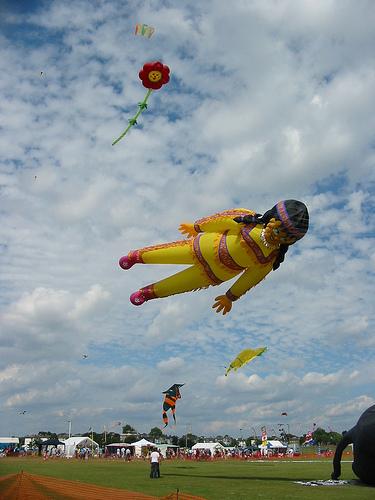Are these kites or balloons?
Give a very brief answer. Kites. What ethnicity or culture is the person in the sky?
Concise answer only. Indian. Is there a flower in the sky?
Be succinct. Yes. 